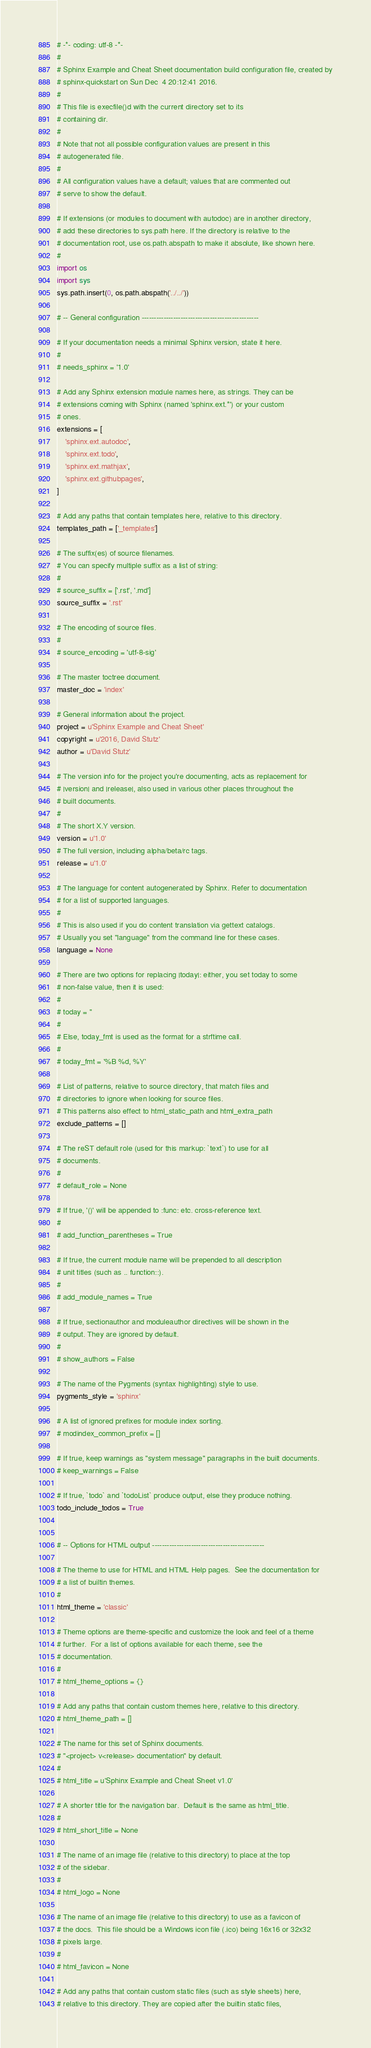<code> <loc_0><loc_0><loc_500><loc_500><_Python_># -*- coding: utf-8 -*-
#
# Sphinx Example and Cheat Sheet documentation build configuration file, created by
# sphinx-quickstart on Sun Dec  4 20:12:41 2016.
#
# This file is execfile()d with the current directory set to its
# containing dir.
#
# Note that not all possible configuration values are present in this
# autogenerated file.
#
# All configuration values have a default; values that are commented out
# serve to show the default.

# If extensions (or modules to document with autodoc) are in another directory,
# add these directories to sys.path here. If the directory is relative to the
# documentation root, use os.path.abspath to make it absolute, like shown here.
#
import os
import sys
sys.path.insert(0, os.path.abspath('../../'))

# -- General configuration ------------------------------------------------

# If your documentation needs a minimal Sphinx version, state it here.
#
# needs_sphinx = '1.0'

# Add any Sphinx extension module names here, as strings. They can be
# extensions coming with Sphinx (named 'sphinx.ext.*') or your custom
# ones.
extensions = [
    'sphinx.ext.autodoc',
    'sphinx.ext.todo',
    'sphinx.ext.mathjax',
    'sphinx.ext.githubpages',
]

# Add any paths that contain templates here, relative to this directory.
templates_path = ['_templates']

# The suffix(es) of source filenames.
# You can specify multiple suffix as a list of string:
#
# source_suffix = ['.rst', '.md']
source_suffix = '.rst'

# The encoding of source files.
#
# source_encoding = 'utf-8-sig'

# The master toctree document.
master_doc = 'index'

# General information about the project.
project = u'Sphinx Example and Cheat Sheet'
copyright = u'2016, David Stutz'
author = u'David Stutz'

# The version info for the project you're documenting, acts as replacement for
# |version| and |release|, also used in various other places throughout the
# built documents.
#
# The short X.Y version.
version = u'1.0'
# The full version, including alpha/beta/rc tags.
release = u'1.0'

# The language for content autogenerated by Sphinx. Refer to documentation
# for a list of supported languages.
#
# This is also used if you do content translation via gettext catalogs.
# Usually you set "language" from the command line for these cases.
language = None

# There are two options for replacing |today|: either, you set today to some
# non-false value, then it is used:
#
# today = ''
#
# Else, today_fmt is used as the format for a strftime call.
#
# today_fmt = '%B %d, %Y'

# List of patterns, relative to source directory, that match files and
# directories to ignore when looking for source files.
# This patterns also effect to html_static_path and html_extra_path
exclude_patterns = []

# The reST default role (used for this markup: `text`) to use for all
# documents.
#
# default_role = None

# If true, '()' will be appended to :func: etc. cross-reference text.
#
# add_function_parentheses = True

# If true, the current module name will be prepended to all description
# unit titles (such as .. function::).
#
# add_module_names = True

# If true, sectionauthor and moduleauthor directives will be shown in the
# output. They are ignored by default.
#
# show_authors = False

# The name of the Pygments (syntax highlighting) style to use.
pygments_style = 'sphinx'

# A list of ignored prefixes for module index sorting.
# modindex_common_prefix = []

# If true, keep warnings as "system message" paragraphs in the built documents.
# keep_warnings = False

# If true, `todo` and `todoList` produce output, else they produce nothing.
todo_include_todos = True


# -- Options for HTML output ----------------------------------------------

# The theme to use for HTML and HTML Help pages.  See the documentation for
# a list of builtin themes.
#
html_theme = 'classic'

# Theme options are theme-specific and customize the look and feel of a theme
# further.  For a list of options available for each theme, see the
# documentation.
#
# html_theme_options = {}

# Add any paths that contain custom themes here, relative to this directory.
# html_theme_path = []

# The name for this set of Sphinx documents.
# "<project> v<release> documentation" by default.
#
# html_title = u'Sphinx Example and Cheat Sheet v1.0'

# A shorter title for the navigation bar.  Default is the same as html_title.
#
# html_short_title = None

# The name of an image file (relative to this directory) to place at the top
# of the sidebar.
#
# html_logo = None

# The name of an image file (relative to this directory) to use as a favicon of
# the docs.  This file should be a Windows icon file (.ico) being 16x16 or 32x32
# pixels large.
#
# html_favicon = None

# Add any paths that contain custom static files (such as style sheets) here,
# relative to this directory. They are copied after the builtin static files,</code> 